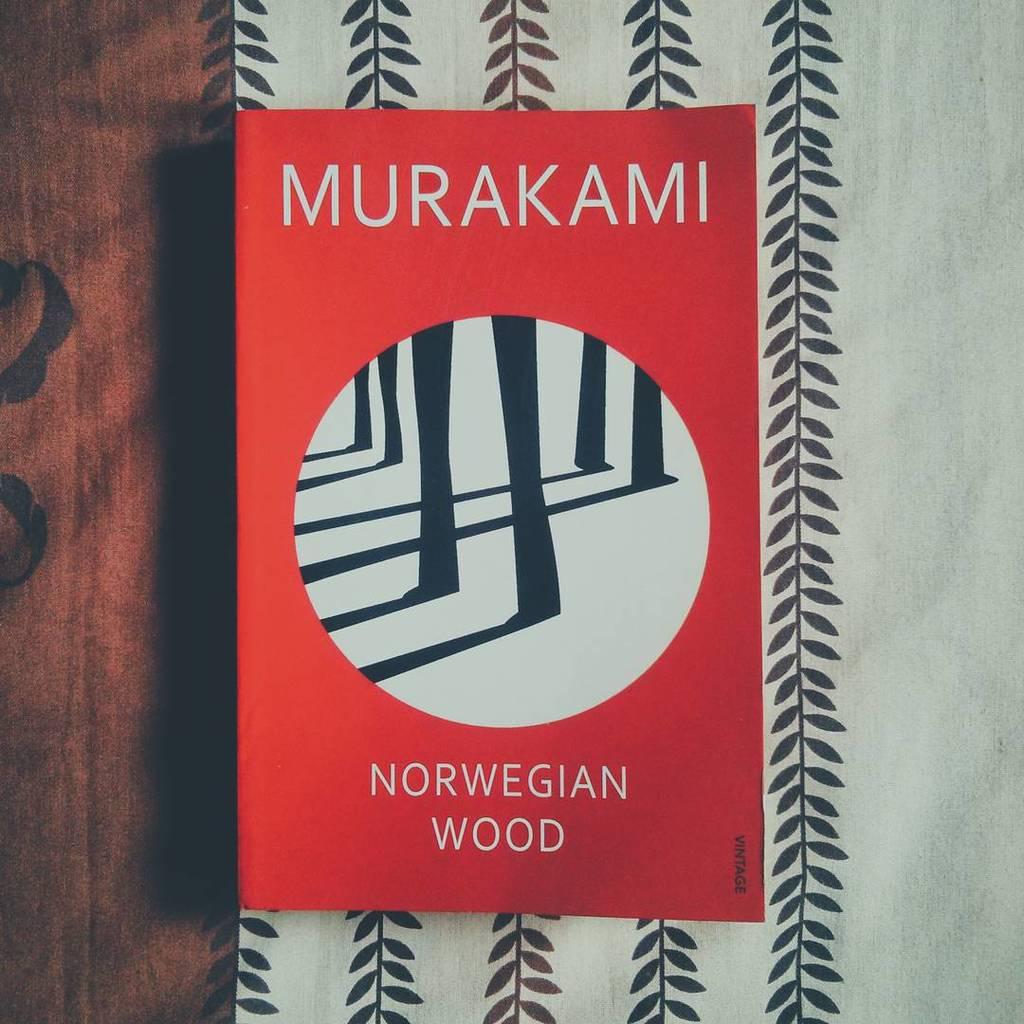Who is the author of the book?
Ensure brevity in your answer.  Murakami. 